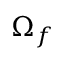Convert formula to latex. <formula><loc_0><loc_0><loc_500><loc_500>\Omega _ { f }</formula> 